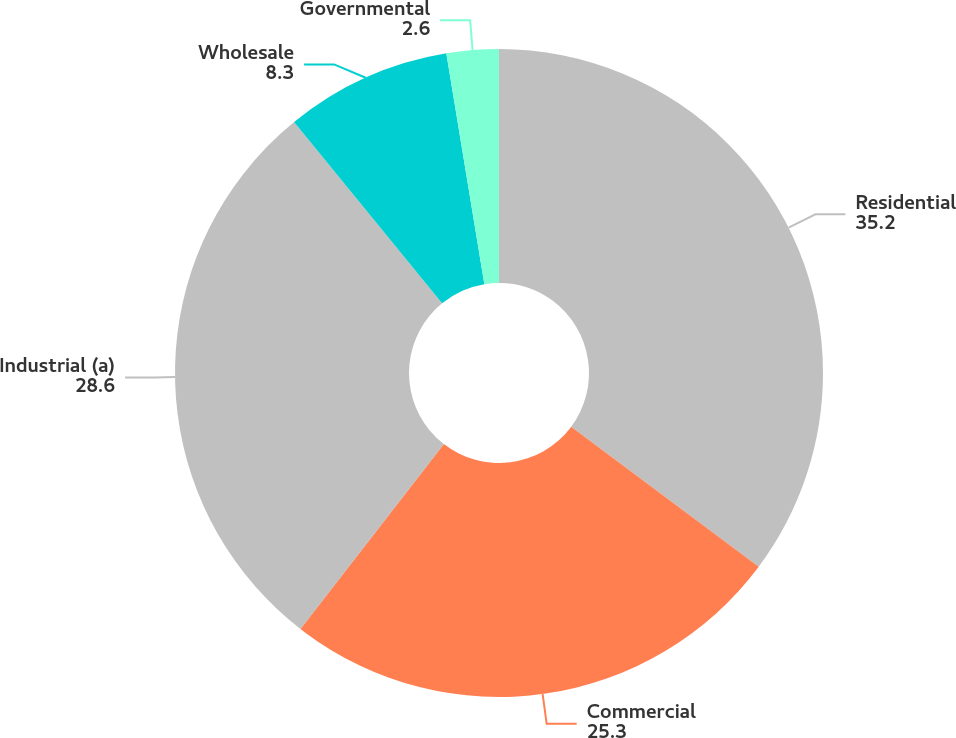Convert chart to OTSL. <chart><loc_0><loc_0><loc_500><loc_500><pie_chart><fcel>Residential<fcel>Commercial<fcel>Industrial (a)<fcel>Wholesale<fcel>Governmental<nl><fcel>35.2%<fcel>25.3%<fcel>28.6%<fcel>8.3%<fcel>2.6%<nl></chart> 